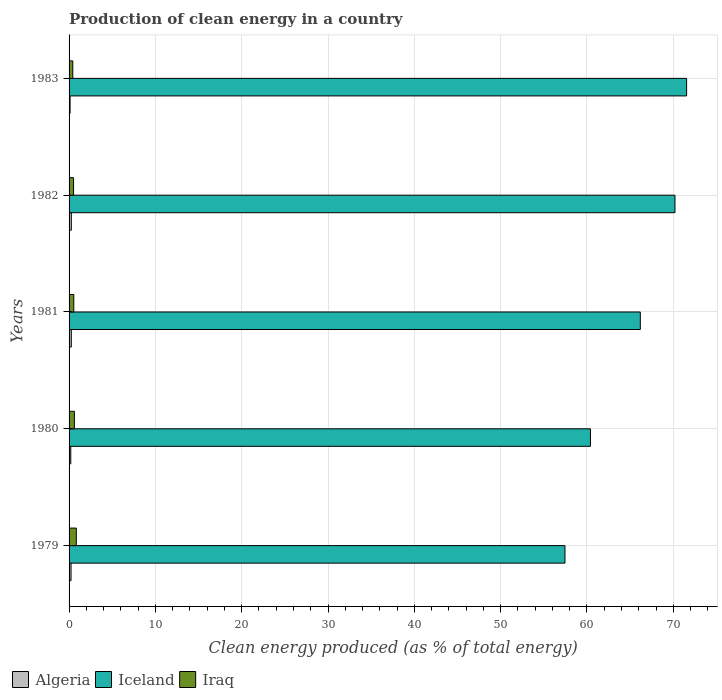How many different coloured bars are there?
Your response must be concise. 3. How many groups of bars are there?
Your answer should be compact. 5. Are the number of bars per tick equal to the number of legend labels?
Offer a very short reply. Yes. Are the number of bars on each tick of the Y-axis equal?
Keep it short and to the point. Yes. How many bars are there on the 5th tick from the bottom?
Keep it short and to the point. 3. What is the label of the 3rd group of bars from the top?
Your answer should be compact. 1981. In how many cases, is the number of bars for a given year not equal to the number of legend labels?
Your answer should be very brief. 0. What is the percentage of clean energy produced in Iceland in 1981?
Keep it short and to the point. 66.18. Across all years, what is the maximum percentage of clean energy produced in Algeria?
Provide a succinct answer. 0.26. Across all years, what is the minimum percentage of clean energy produced in Algeria?
Ensure brevity in your answer.  0.12. In which year was the percentage of clean energy produced in Iraq maximum?
Give a very brief answer. 1979. In which year was the percentage of clean energy produced in Iraq minimum?
Offer a terse response. 1983. What is the total percentage of clean energy produced in Iceland in the graph?
Make the answer very short. 325.77. What is the difference between the percentage of clean energy produced in Algeria in 1980 and that in 1981?
Offer a terse response. -0.06. What is the difference between the percentage of clean energy produced in Algeria in 1980 and the percentage of clean energy produced in Iraq in 1979?
Your answer should be compact. -0.64. What is the average percentage of clean energy produced in Algeria per year?
Provide a short and direct response. 0.21. In the year 1980, what is the difference between the percentage of clean energy produced in Algeria and percentage of clean energy produced in Iceland?
Provide a short and direct response. -60.2. In how many years, is the percentage of clean energy produced in Algeria greater than 44 %?
Keep it short and to the point. 0. What is the ratio of the percentage of clean energy produced in Iceland in 1979 to that in 1980?
Your answer should be compact. 0.95. Is the percentage of clean energy produced in Iraq in 1979 less than that in 1981?
Ensure brevity in your answer.  No. What is the difference between the highest and the second highest percentage of clean energy produced in Iraq?
Offer a very short reply. 0.22. What is the difference between the highest and the lowest percentage of clean energy produced in Algeria?
Give a very brief answer. 0.14. In how many years, is the percentage of clean energy produced in Iraq greater than the average percentage of clean energy produced in Iraq taken over all years?
Your response must be concise. 2. What does the 3rd bar from the top in 1983 represents?
Keep it short and to the point. Algeria. What does the 2nd bar from the bottom in 1981 represents?
Give a very brief answer. Iceland. What is the difference between two consecutive major ticks on the X-axis?
Ensure brevity in your answer.  10. Are the values on the major ticks of X-axis written in scientific E-notation?
Ensure brevity in your answer.  No. Where does the legend appear in the graph?
Your answer should be very brief. Bottom left. What is the title of the graph?
Provide a succinct answer. Production of clean energy in a country. Does "Monaco" appear as one of the legend labels in the graph?
Your response must be concise. No. What is the label or title of the X-axis?
Give a very brief answer. Clean energy produced (as % of total energy). What is the Clean energy produced (as % of total energy) in Algeria in 1979?
Provide a succinct answer. 0.23. What is the Clean energy produced (as % of total energy) in Iceland in 1979?
Make the answer very short. 57.45. What is the Clean energy produced (as % of total energy) of Iraq in 1979?
Ensure brevity in your answer.  0.84. What is the Clean energy produced (as % of total energy) of Algeria in 1980?
Offer a terse response. 0.2. What is the Clean energy produced (as % of total energy) in Iceland in 1980?
Your answer should be compact. 60.4. What is the Clean energy produced (as % of total energy) in Iraq in 1980?
Offer a very short reply. 0.61. What is the Clean energy produced (as % of total energy) of Algeria in 1981?
Offer a very short reply. 0.26. What is the Clean energy produced (as % of total energy) of Iceland in 1981?
Give a very brief answer. 66.18. What is the Clean energy produced (as % of total energy) in Iraq in 1981?
Provide a succinct answer. 0.55. What is the Clean energy produced (as % of total energy) in Algeria in 1982?
Ensure brevity in your answer.  0.26. What is the Clean energy produced (as % of total energy) in Iceland in 1982?
Offer a very short reply. 70.19. What is the Clean energy produced (as % of total energy) in Iraq in 1982?
Make the answer very short. 0.52. What is the Clean energy produced (as % of total energy) of Algeria in 1983?
Ensure brevity in your answer.  0.12. What is the Clean energy produced (as % of total energy) in Iceland in 1983?
Offer a very short reply. 71.54. What is the Clean energy produced (as % of total energy) of Iraq in 1983?
Ensure brevity in your answer.  0.43. Across all years, what is the maximum Clean energy produced (as % of total energy) of Algeria?
Your response must be concise. 0.26. Across all years, what is the maximum Clean energy produced (as % of total energy) of Iceland?
Offer a terse response. 71.54. Across all years, what is the maximum Clean energy produced (as % of total energy) of Iraq?
Your response must be concise. 0.84. Across all years, what is the minimum Clean energy produced (as % of total energy) of Algeria?
Keep it short and to the point. 0.12. Across all years, what is the minimum Clean energy produced (as % of total energy) in Iceland?
Your response must be concise. 57.45. Across all years, what is the minimum Clean energy produced (as % of total energy) in Iraq?
Your answer should be very brief. 0.43. What is the total Clean energy produced (as % of total energy) in Algeria in the graph?
Provide a succinct answer. 1.06. What is the total Clean energy produced (as % of total energy) of Iceland in the graph?
Your response must be concise. 325.77. What is the total Clean energy produced (as % of total energy) of Iraq in the graph?
Make the answer very short. 2.95. What is the difference between the Clean energy produced (as % of total energy) of Algeria in 1979 and that in 1980?
Give a very brief answer. 0.03. What is the difference between the Clean energy produced (as % of total energy) in Iceland in 1979 and that in 1980?
Make the answer very short. -2.95. What is the difference between the Clean energy produced (as % of total energy) of Iraq in 1979 and that in 1980?
Your response must be concise. 0.22. What is the difference between the Clean energy produced (as % of total energy) of Algeria in 1979 and that in 1981?
Your answer should be compact. -0.03. What is the difference between the Clean energy produced (as % of total energy) in Iceland in 1979 and that in 1981?
Ensure brevity in your answer.  -8.73. What is the difference between the Clean energy produced (as % of total energy) of Iraq in 1979 and that in 1981?
Provide a succinct answer. 0.29. What is the difference between the Clean energy produced (as % of total energy) of Algeria in 1979 and that in 1982?
Offer a terse response. -0.03. What is the difference between the Clean energy produced (as % of total energy) in Iceland in 1979 and that in 1982?
Offer a very short reply. -12.74. What is the difference between the Clean energy produced (as % of total energy) in Iraq in 1979 and that in 1982?
Give a very brief answer. 0.32. What is the difference between the Clean energy produced (as % of total energy) in Algeria in 1979 and that in 1983?
Keep it short and to the point. 0.11. What is the difference between the Clean energy produced (as % of total energy) of Iceland in 1979 and that in 1983?
Your answer should be compact. -14.09. What is the difference between the Clean energy produced (as % of total energy) in Iraq in 1979 and that in 1983?
Provide a succinct answer. 0.41. What is the difference between the Clean energy produced (as % of total energy) of Algeria in 1980 and that in 1981?
Provide a short and direct response. -0.06. What is the difference between the Clean energy produced (as % of total energy) of Iceland in 1980 and that in 1981?
Keep it short and to the point. -5.78. What is the difference between the Clean energy produced (as % of total energy) in Iraq in 1980 and that in 1981?
Offer a very short reply. 0.07. What is the difference between the Clean energy produced (as % of total energy) of Algeria in 1980 and that in 1982?
Offer a very short reply. -0.06. What is the difference between the Clean energy produced (as % of total energy) in Iceland in 1980 and that in 1982?
Your answer should be very brief. -9.79. What is the difference between the Clean energy produced (as % of total energy) in Iraq in 1980 and that in 1982?
Keep it short and to the point. 0.1. What is the difference between the Clean energy produced (as % of total energy) in Algeria in 1980 and that in 1983?
Make the answer very short. 0.08. What is the difference between the Clean energy produced (as % of total energy) in Iceland in 1980 and that in 1983?
Provide a succinct answer. -11.14. What is the difference between the Clean energy produced (as % of total energy) in Iraq in 1980 and that in 1983?
Make the answer very short. 0.19. What is the difference between the Clean energy produced (as % of total energy) of Algeria in 1981 and that in 1982?
Your response must be concise. -0. What is the difference between the Clean energy produced (as % of total energy) in Iceland in 1981 and that in 1982?
Offer a very short reply. -4.01. What is the difference between the Clean energy produced (as % of total energy) of Iraq in 1981 and that in 1982?
Provide a short and direct response. 0.03. What is the difference between the Clean energy produced (as % of total energy) of Algeria in 1981 and that in 1983?
Offer a terse response. 0.14. What is the difference between the Clean energy produced (as % of total energy) of Iceland in 1981 and that in 1983?
Keep it short and to the point. -5.36. What is the difference between the Clean energy produced (as % of total energy) of Iraq in 1981 and that in 1983?
Offer a very short reply. 0.12. What is the difference between the Clean energy produced (as % of total energy) in Algeria in 1982 and that in 1983?
Provide a short and direct response. 0.14. What is the difference between the Clean energy produced (as % of total energy) in Iceland in 1982 and that in 1983?
Provide a short and direct response. -1.35. What is the difference between the Clean energy produced (as % of total energy) of Iraq in 1982 and that in 1983?
Keep it short and to the point. 0.09. What is the difference between the Clean energy produced (as % of total energy) of Algeria in 1979 and the Clean energy produced (as % of total energy) of Iceland in 1980?
Offer a terse response. -60.17. What is the difference between the Clean energy produced (as % of total energy) in Algeria in 1979 and the Clean energy produced (as % of total energy) in Iraq in 1980?
Ensure brevity in your answer.  -0.39. What is the difference between the Clean energy produced (as % of total energy) of Iceland in 1979 and the Clean energy produced (as % of total energy) of Iraq in 1980?
Provide a succinct answer. 56.83. What is the difference between the Clean energy produced (as % of total energy) in Algeria in 1979 and the Clean energy produced (as % of total energy) in Iceland in 1981?
Ensure brevity in your answer.  -65.95. What is the difference between the Clean energy produced (as % of total energy) in Algeria in 1979 and the Clean energy produced (as % of total energy) in Iraq in 1981?
Provide a short and direct response. -0.32. What is the difference between the Clean energy produced (as % of total energy) of Iceland in 1979 and the Clean energy produced (as % of total energy) of Iraq in 1981?
Give a very brief answer. 56.9. What is the difference between the Clean energy produced (as % of total energy) of Algeria in 1979 and the Clean energy produced (as % of total energy) of Iceland in 1982?
Your answer should be compact. -69.97. What is the difference between the Clean energy produced (as % of total energy) in Algeria in 1979 and the Clean energy produced (as % of total energy) in Iraq in 1982?
Give a very brief answer. -0.29. What is the difference between the Clean energy produced (as % of total energy) in Iceland in 1979 and the Clean energy produced (as % of total energy) in Iraq in 1982?
Keep it short and to the point. 56.93. What is the difference between the Clean energy produced (as % of total energy) in Algeria in 1979 and the Clean energy produced (as % of total energy) in Iceland in 1983?
Provide a succinct answer. -71.31. What is the difference between the Clean energy produced (as % of total energy) in Algeria in 1979 and the Clean energy produced (as % of total energy) in Iraq in 1983?
Give a very brief answer. -0.2. What is the difference between the Clean energy produced (as % of total energy) in Iceland in 1979 and the Clean energy produced (as % of total energy) in Iraq in 1983?
Provide a short and direct response. 57.02. What is the difference between the Clean energy produced (as % of total energy) in Algeria in 1980 and the Clean energy produced (as % of total energy) in Iceland in 1981?
Offer a very short reply. -65.98. What is the difference between the Clean energy produced (as % of total energy) of Algeria in 1980 and the Clean energy produced (as % of total energy) of Iraq in 1981?
Make the answer very short. -0.35. What is the difference between the Clean energy produced (as % of total energy) of Iceland in 1980 and the Clean energy produced (as % of total energy) of Iraq in 1981?
Your answer should be very brief. 59.85. What is the difference between the Clean energy produced (as % of total energy) in Algeria in 1980 and the Clean energy produced (as % of total energy) in Iceland in 1982?
Give a very brief answer. -70. What is the difference between the Clean energy produced (as % of total energy) in Algeria in 1980 and the Clean energy produced (as % of total energy) in Iraq in 1982?
Keep it short and to the point. -0.32. What is the difference between the Clean energy produced (as % of total energy) of Iceland in 1980 and the Clean energy produced (as % of total energy) of Iraq in 1982?
Your response must be concise. 59.88. What is the difference between the Clean energy produced (as % of total energy) in Algeria in 1980 and the Clean energy produced (as % of total energy) in Iceland in 1983?
Your answer should be compact. -71.35. What is the difference between the Clean energy produced (as % of total energy) of Algeria in 1980 and the Clean energy produced (as % of total energy) of Iraq in 1983?
Ensure brevity in your answer.  -0.23. What is the difference between the Clean energy produced (as % of total energy) in Iceland in 1980 and the Clean energy produced (as % of total energy) in Iraq in 1983?
Provide a short and direct response. 59.97. What is the difference between the Clean energy produced (as % of total energy) of Algeria in 1981 and the Clean energy produced (as % of total energy) of Iceland in 1982?
Give a very brief answer. -69.93. What is the difference between the Clean energy produced (as % of total energy) of Algeria in 1981 and the Clean energy produced (as % of total energy) of Iraq in 1982?
Your answer should be very brief. -0.26. What is the difference between the Clean energy produced (as % of total energy) in Iceland in 1981 and the Clean energy produced (as % of total energy) in Iraq in 1982?
Offer a terse response. 65.66. What is the difference between the Clean energy produced (as % of total energy) in Algeria in 1981 and the Clean energy produced (as % of total energy) in Iceland in 1983?
Provide a short and direct response. -71.28. What is the difference between the Clean energy produced (as % of total energy) of Algeria in 1981 and the Clean energy produced (as % of total energy) of Iraq in 1983?
Your answer should be compact. -0.17. What is the difference between the Clean energy produced (as % of total energy) of Iceland in 1981 and the Clean energy produced (as % of total energy) of Iraq in 1983?
Your response must be concise. 65.75. What is the difference between the Clean energy produced (as % of total energy) in Algeria in 1982 and the Clean energy produced (as % of total energy) in Iceland in 1983?
Keep it short and to the point. -71.28. What is the difference between the Clean energy produced (as % of total energy) of Algeria in 1982 and the Clean energy produced (as % of total energy) of Iraq in 1983?
Offer a very short reply. -0.17. What is the difference between the Clean energy produced (as % of total energy) in Iceland in 1982 and the Clean energy produced (as % of total energy) in Iraq in 1983?
Provide a succinct answer. 69.76. What is the average Clean energy produced (as % of total energy) of Algeria per year?
Provide a succinct answer. 0.21. What is the average Clean energy produced (as % of total energy) in Iceland per year?
Give a very brief answer. 65.15. What is the average Clean energy produced (as % of total energy) of Iraq per year?
Keep it short and to the point. 0.59. In the year 1979, what is the difference between the Clean energy produced (as % of total energy) in Algeria and Clean energy produced (as % of total energy) in Iceland?
Give a very brief answer. -57.22. In the year 1979, what is the difference between the Clean energy produced (as % of total energy) of Algeria and Clean energy produced (as % of total energy) of Iraq?
Provide a succinct answer. -0.61. In the year 1979, what is the difference between the Clean energy produced (as % of total energy) in Iceland and Clean energy produced (as % of total energy) in Iraq?
Make the answer very short. 56.61. In the year 1980, what is the difference between the Clean energy produced (as % of total energy) of Algeria and Clean energy produced (as % of total energy) of Iceland?
Make the answer very short. -60.2. In the year 1980, what is the difference between the Clean energy produced (as % of total energy) of Algeria and Clean energy produced (as % of total energy) of Iraq?
Provide a succinct answer. -0.42. In the year 1980, what is the difference between the Clean energy produced (as % of total energy) in Iceland and Clean energy produced (as % of total energy) in Iraq?
Provide a short and direct response. 59.79. In the year 1981, what is the difference between the Clean energy produced (as % of total energy) of Algeria and Clean energy produced (as % of total energy) of Iceland?
Your answer should be very brief. -65.92. In the year 1981, what is the difference between the Clean energy produced (as % of total energy) in Algeria and Clean energy produced (as % of total energy) in Iraq?
Your answer should be compact. -0.29. In the year 1981, what is the difference between the Clean energy produced (as % of total energy) of Iceland and Clean energy produced (as % of total energy) of Iraq?
Offer a terse response. 65.63. In the year 1982, what is the difference between the Clean energy produced (as % of total energy) of Algeria and Clean energy produced (as % of total energy) of Iceland?
Offer a very short reply. -69.93. In the year 1982, what is the difference between the Clean energy produced (as % of total energy) in Algeria and Clean energy produced (as % of total energy) in Iraq?
Offer a terse response. -0.26. In the year 1982, what is the difference between the Clean energy produced (as % of total energy) in Iceland and Clean energy produced (as % of total energy) in Iraq?
Ensure brevity in your answer.  69.68. In the year 1983, what is the difference between the Clean energy produced (as % of total energy) in Algeria and Clean energy produced (as % of total energy) in Iceland?
Your answer should be compact. -71.42. In the year 1983, what is the difference between the Clean energy produced (as % of total energy) of Algeria and Clean energy produced (as % of total energy) of Iraq?
Your response must be concise. -0.31. In the year 1983, what is the difference between the Clean energy produced (as % of total energy) in Iceland and Clean energy produced (as % of total energy) in Iraq?
Provide a short and direct response. 71.11. What is the ratio of the Clean energy produced (as % of total energy) in Algeria in 1979 to that in 1980?
Provide a succinct answer. 1.15. What is the ratio of the Clean energy produced (as % of total energy) of Iceland in 1979 to that in 1980?
Your response must be concise. 0.95. What is the ratio of the Clean energy produced (as % of total energy) in Iraq in 1979 to that in 1980?
Ensure brevity in your answer.  1.36. What is the ratio of the Clean energy produced (as % of total energy) of Algeria in 1979 to that in 1981?
Provide a short and direct response. 0.88. What is the ratio of the Clean energy produced (as % of total energy) of Iceland in 1979 to that in 1981?
Give a very brief answer. 0.87. What is the ratio of the Clean energy produced (as % of total energy) of Iraq in 1979 to that in 1981?
Your answer should be compact. 1.53. What is the ratio of the Clean energy produced (as % of total energy) of Algeria in 1979 to that in 1982?
Provide a succinct answer. 0.88. What is the ratio of the Clean energy produced (as % of total energy) in Iceland in 1979 to that in 1982?
Offer a very short reply. 0.82. What is the ratio of the Clean energy produced (as % of total energy) of Iraq in 1979 to that in 1982?
Offer a terse response. 1.62. What is the ratio of the Clean energy produced (as % of total energy) in Algeria in 1979 to that in 1983?
Provide a short and direct response. 1.93. What is the ratio of the Clean energy produced (as % of total energy) of Iceland in 1979 to that in 1983?
Provide a short and direct response. 0.8. What is the ratio of the Clean energy produced (as % of total energy) of Iraq in 1979 to that in 1983?
Ensure brevity in your answer.  1.95. What is the ratio of the Clean energy produced (as % of total energy) in Algeria in 1980 to that in 1981?
Offer a terse response. 0.76. What is the ratio of the Clean energy produced (as % of total energy) of Iceland in 1980 to that in 1981?
Make the answer very short. 0.91. What is the ratio of the Clean energy produced (as % of total energy) of Iraq in 1980 to that in 1981?
Offer a very short reply. 1.12. What is the ratio of the Clean energy produced (as % of total energy) of Algeria in 1980 to that in 1982?
Offer a terse response. 0.76. What is the ratio of the Clean energy produced (as % of total energy) of Iceland in 1980 to that in 1982?
Your response must be concise. 0.86. What is the ratio of the Clean energy produced (as % of total energy) of Iraq in 1980 to that in 1982?
Your answer should be compact. 1.19. What is the ratio of the Clean energy produced (as % of total energy) of Algeria in 1980 to that in 1983?
Provide a short and direct response. 1.67. What is the ratio of the Clean energy produced (as % of total energy) of Iceland in 1980 to that in 1983?
Provide a succinct answer. 0.84. What is the ratio of the Clean energy produced (as % of total energy) of Iraq in 1980 to that in 1983?
Offer a very short reply. 1.43. What is the ratio of the Clean energy produced (as % of total energy) of Algeria in 1981 to that in 1982?
Your response must be concise. 1. What is the ratio of the Clean energy produced (as % of total energy) of Iceland in 1981 to that in 1982?
Give a very brief answer. 0.94. What is the ratio of the Clean energy produced (as % of total energy) in Iraq in 1981 to that in 1982?
Your answer should be compact. 1.06. What is the ratio of the Clean energy produced (as % of total energy) of Algeria in 1981 to that in 1983?
Ensure brevity in your answer.  2.19. What is the ratio of the Clean energy produced (as % of total energy) of Iceland in 1981 to that in 1983?
Your answer should be compact. 0.93. What is the ratio of the Clean energy produced (as % of total energy) of Iraq in 1981 to that in 1983?
Your answer should be compact. 1.28. What is the ratio of the Clean energy produced (as % of total energy) in Algeria in 1982 to that in 1983?
Your response must be concise. 2.2. What is the ratio of the Clean energy produced (as % of total energy) in Iceland in 1982 to that in 1983?
Provide a short and direct response. 0.98. What is the ratio of the Clean energy produced (as % of total energy) in Iraq in 1982 to that in 1983?
Your response must be concise. 1.21. What is the difference between the highest and the second highest Clean energy produced (as % of total energy) of Algeria?
Your answer should be very brief. 0. What is the difference between the highest and the second highest Clean energy produced (as % of total energy) in Iceland?
Give a very brief answer. 1.35. What is the difference between the highest and the second highest Clean energy produced (as % of total energy) of Iraq?
Your answer should be compact. 0.22. What is the difference between the highest and the lowest Clean energy produced (as % of total energy) in Algeria?
Your answer should be compact. 0.14. What is the difference between the highest and the lowest Clean energy produced (as % of total energy) in Iceland?
Keep it short and to the point. 14.09. What is the difference between the highest and the lowest Clean energy produced (as % of total energy) in Iraq?
Your response must be concise. 0.41. 